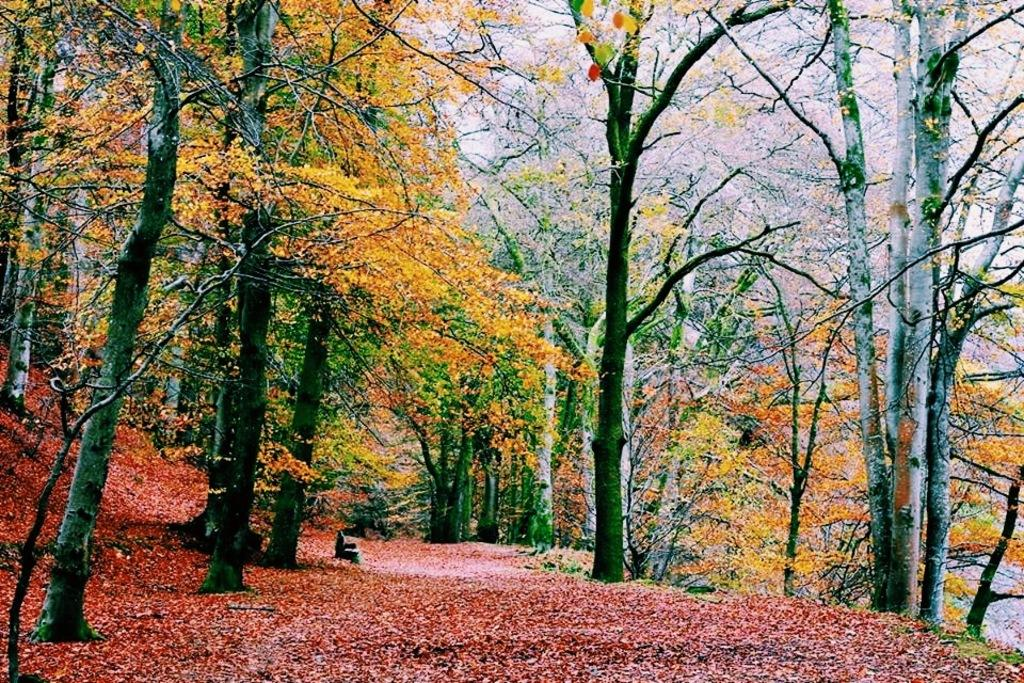What type of vegetation can be seen in the image? There are trees in the image. What is on the ground beneath the trees? There are leaves on the ground in the image. What part of the natural environment is visible in the image? The sky is visible in the image. What type of comb can be seen in the image? There is no comb present in the image. What type of building is visible in the image? There is no building visible in the image; it features trees and leaves on the ground. 